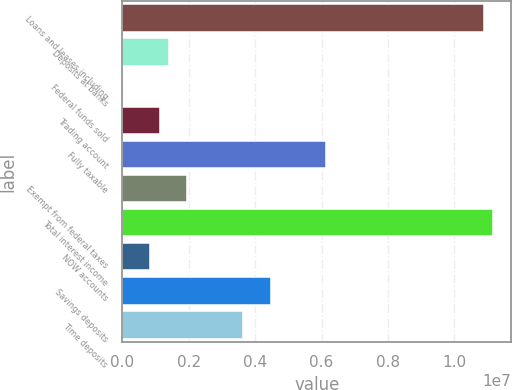Convert chart to OTSL. <chart><loc_0><loc_0><loc_500><loc_500><bar_chart><fcel>Loans and leases including<fcel>Deposits at banks<fcel>Federal funds sold<fcel>Trading account<fcel>Fully taxable<fcel>Exempt from federal taxes<fcel>Total interest income<fcel>NOW accounts<fcel>Savings deposits<fcel>Time deposits<nl><fcel>1.0889e+07<fcel>1.39607e+06<fcel>57<fcel>1.11687e+06<fcel>6.14252e+06<fcel>1.95448e+06<fcel>1.11682e+07<fcel>837666<fcel>4.4673e+06<fcel>3.6297e+06<nl></chart> 